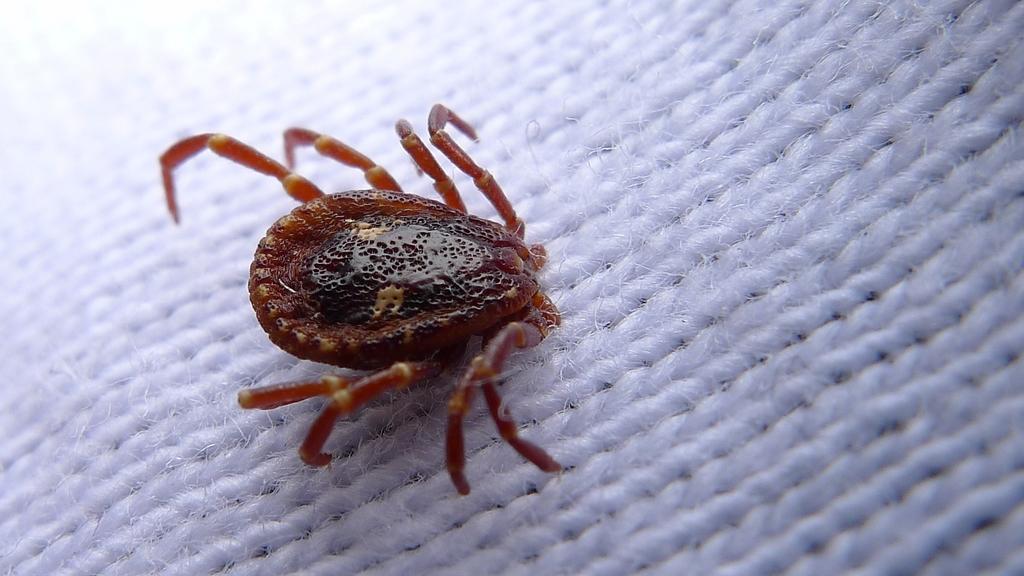Please provide a concise description of this image. In this image there is an insect on a cloth. 